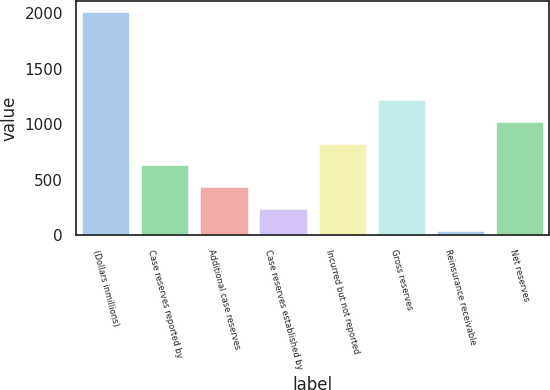Convert chart. <chart><loc_0><loc_0><loc_500><loc_500><bar_chart><fcel>(Dollars inmillions)<fcel>Case reserves reported by<fcel>Additional case reserves<fcel>Case reserves established by<fcel>Incurred but not reported<fcel>Gross reserves<fcel>Reinsurance receivable<fcel>Net reserves<nl><fcel>2008<fcel>628.79<fcel>431.76<fcel>234.73<fcel>825.82<fcel>1219.88<fcel>37.7<fcel>1022.85<nl></chart> 